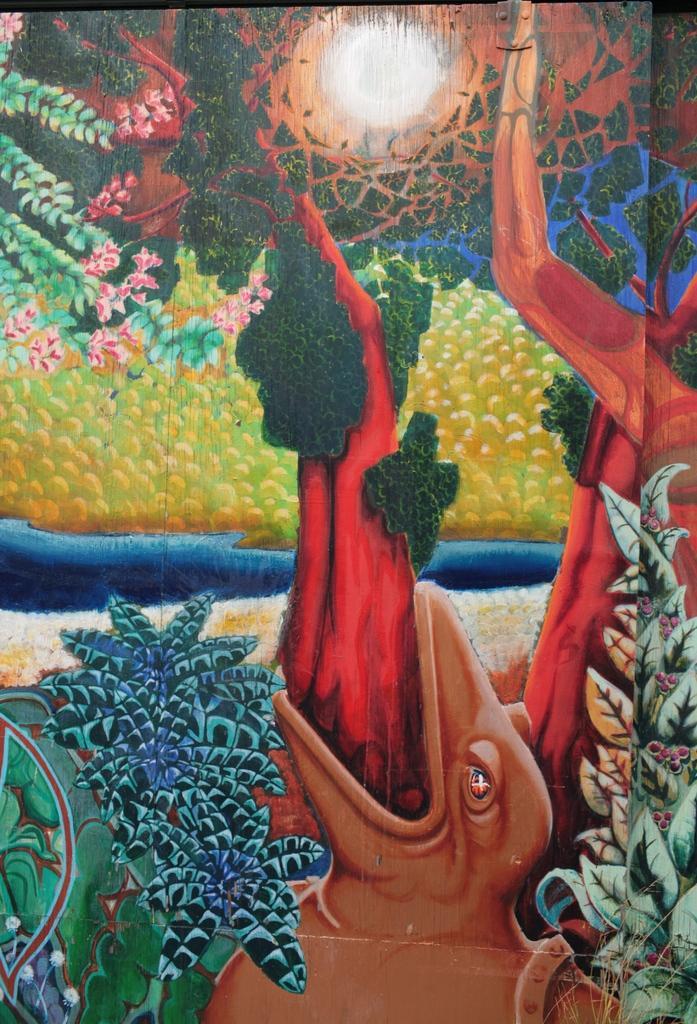Describe this image in one or two sentences. There is a painting in which, there is an animal having red color tongue on which, there are green color objects. On both sides of this animal, there are plants which are having flowers. In the background, there is a moon in the sky, there are flowers and there are trees. 